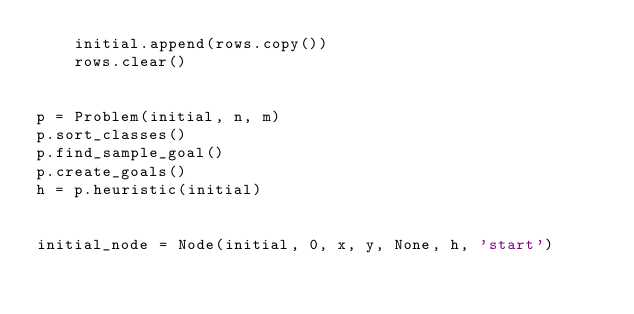Convert code to text. <code><loc_0><loc_0><loc_500><loc_500><_Python_>    initial.append(rows.copy())
    rows.clear()


p = Problem(initial, n, m)
p.sort_classes()
p.find_sample_goal()
p.create_goals()
h = p.heuristic(initial)


initial_node = Node(initial, 0, x, y, None, h, 'start')


</code> 